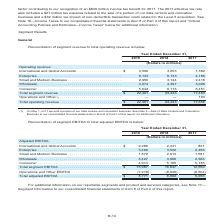According to Centurylink's financial document, What portion of business under Operations and Other was sold? data centers and colocation business. The document states: "x expense related to the sale of a portion of our data centers and colocation business and a $32 million tax impact of non-deductible transaction cost..." Also, What is the total segment revenue in 2019? According to the financial document, $22,401 (in millions). The relevant text states: "Total segment revenue . $ 22,401 23,443 17,463 Operations and Other (1) . — — 193..." Also, What components are under operating revenue? The document contains multiple relevant values: International and Global Accounts, Enterprise, Small and Medium Business, Wholesale, Consumer. From the document: "ational and Global Accounts . $ 3,596 3,653 1,382 Enterprise . 6,133 6,133 4,186 Small and Medium Business . 2,956 3,144 2,418 Wholesale . 4,074 4,397..." Also, How many items are there under operating revenue? Counting the relevant items in the document: International and Global Accounts, Enterprise, Small and Medium Business, Wholesale, Consumer, I find 5 instances. The key data points involved are: Consumer, Enterprise, International and Global Accounts. Also, can you calculate: What is the difference between Wholesale and Consumer in 2019?  Based on the calculation: 5,642-4,074, the result is 1568 (in millions). This is based on the information: "d Medium Business . 2,956 3,144 2,418 Wholesale . 4,074 4,397 3,026 Consumer . 5,642 6,116 6,451 44 2,418 Wholesale . 4,074 4,397 3,026 Consumer . 5,642 6,116 6,451..." The key data points involved are: 4,074, 5,642. Also, can you calculate: What is the percentage change in total operating revenue in 2019 from 2018? To answer this question, I need to perform calculations using the financial data. The calculation is: (22,401-23,443)/23,443, which equals -4.44 (percentage). This is based on the information: "Total segment revenue . $ 22,401 23,443 17,463 Operations and Other (1) . — — 193 Total segment revenue . $ 22,401 23,443 17,463 Operations and Other (1) . — — 193..." The key data points involved are: 22,401, 23,443. 